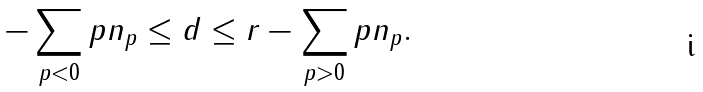Convert formula to latex. <formula><loc_0><loc_0><loc_500><loc_500>- \sum _ { p < 0 } p n _ { p } \leq d \leq r - \sum _ { p > 0 } p n _ { p } .</formula> 